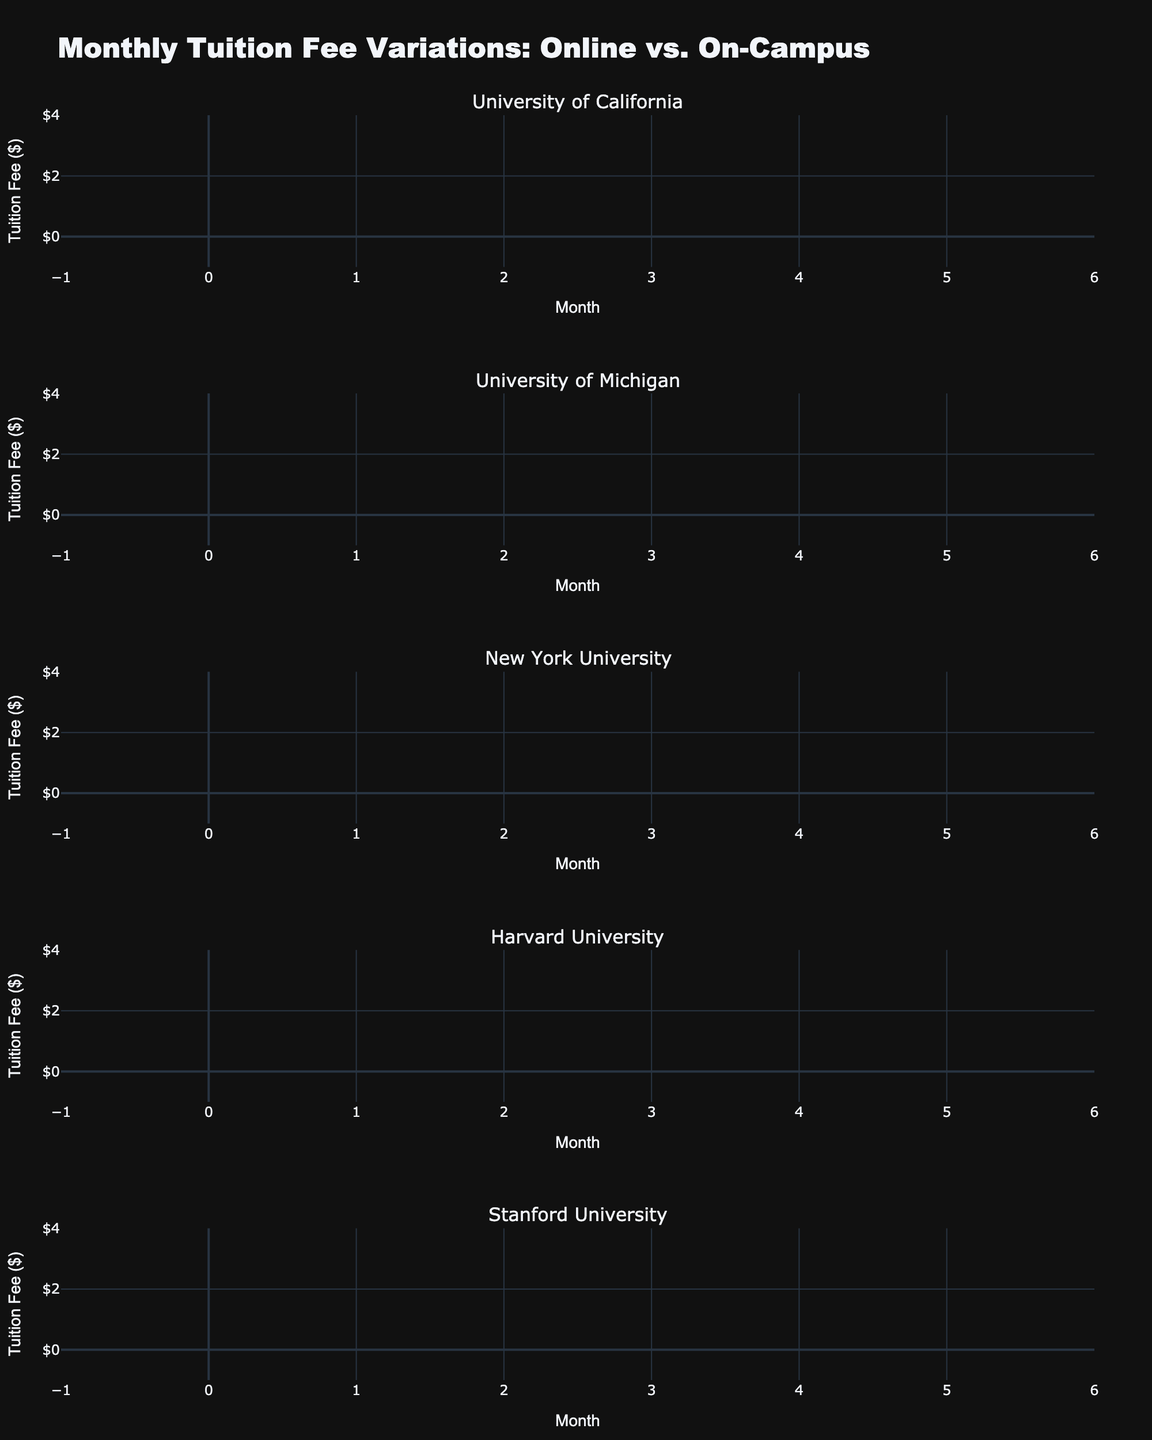What's the title of the figure? The title of the figure is located at the top and is clearly visible in larger and bold text.
Answer: Monthly Tuition Fee Variations: Online vs. On-Campus What are the two program types compared in the figure? The legend and the candlestick colors indicate the two program types being compared: 'Online' and 'On-Campus'.
Answer: Online and On-Campus Which university shows the highest tuition fee for On-Campus programs in January? By inspecting the candlesticks for different universities in January, we find the On-Campus program with the highest close value (at the top of the body). For January, Harvard University shows the highest tuition fee for On-Campus at $3700.
Answer: Harvard University What is the pattern of tuition fees for Online programs in February across all universities? For February, observe the candle positions of Online programs for each university. University of California: $2050, University of Michigan: $1850, New York University: $2250, Harvard University: $3150, Stanford University: $2800. By visual inspection, Harvard University shows the highest, followed by New York University, Stanford University, University of California, and lastly University of Michigan.
Answer: Varies, highest at Harvard, lowest at Michigan What is the difference in the closing tuition fee between Online and On-Campus programs at Stanford University in February? For Stanford University in February, observe the closing values: Online is $2800 and On-Campus is $3450. Calculate the difference as $3450 - $2800.
Answer: $650 Which program type shows more variability in tuition fees for University of Michigan in January? For University of Michigan in January, compare the range (High - Low) for Online (1900 - 1700 = 200) and On-Campus (2300 - 2000 = 300). On-Campus shows more variation.
Answer: On-Campus How do the closing tuition fees for On-Campus programs in February compare across all universities? For February, check the closing values of On-Campus programs: University of California: $2550, University of Michigan: $2250, New York University: $2850, Harvard University: $3750, Stanford University: $3450.
Answer: Highest at Harvard University, lowest at University of Michigan What is the average closing fee for Online programs in January across all universities? For January, the closing values for Online programs are: UC: $2000, UM: $1800, NYU: $2200, Harvard: $3100, Stanford: $2750. Sum these values and divide by the number of data points: (2000+1800+2200+3100+2750)/5.
Answer: $2370 Is there any university where the closing tuition fees for Online and On-Campus programs are the same in any month? Inspect each university's closing fees for Online and On-Campus for both January and February. No university has the same closing fees for both programs in any month.
Answer: No 